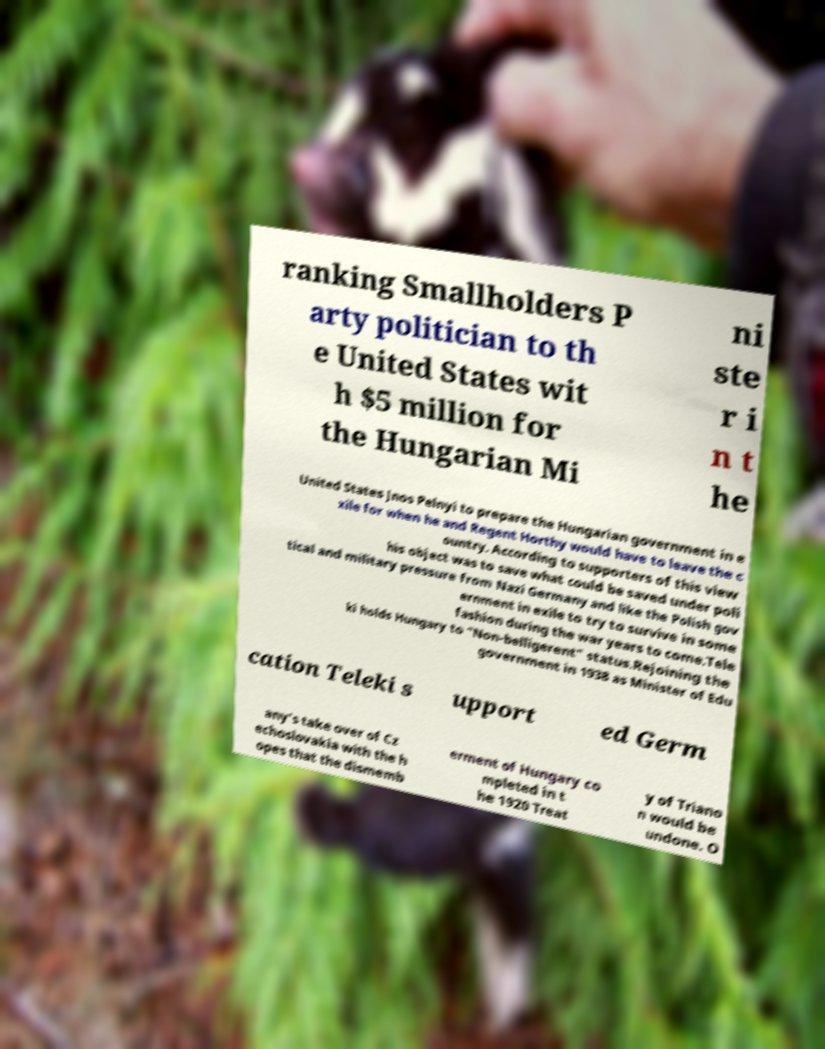What messages or text are displayed in this image? I need them in a readable, typed format. ranking Smallholders P arty politician to th e United States wit h $5 million for the Hungarian Mi ni ste r i n t he United States Jnos Pelnyi to prepare the Hungarian government in e xile for when he and Regent Horthy would have to leave the c ountry. According to supporters of this view his object was to save what could be saved under poli tical and military pressure from Nazi Germany and like the Polish gov ernment in exile to try to survive in some fashion during the war years to come.Tele ki holds Hungary to "Non-belligerent" status.Rejoining the government in 1938 as Minister of Edu cation Teleki s upport ed Germ any's take over of Cz echoslovakia with the h opes that the dismemb erment of Hungary co mpleted in t he 1920 Treat y of Triano n would be undone. O 